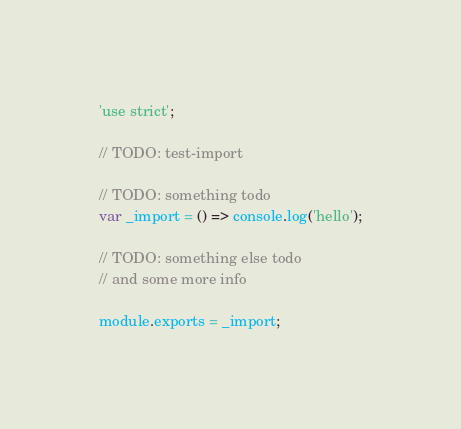Convert code to text. <code><loc_0><loc_0><loc_500><loc_500><_JavaScript_>'use strict';

// TODO: test-import

// TODO: something todo
var _import = () => console.log('hello');

// TODO: something else todo
// and some more info

module.exports = _import;
</code> 